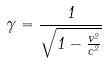Convert formula to latex. <formula><loc_0><loc_0><loc_500><loc_500>\gamma = \frac { 1 } { \sqrt { 1 - \frac { v ^ { 2 } } { c ^ { 2 } } } }</formula> 